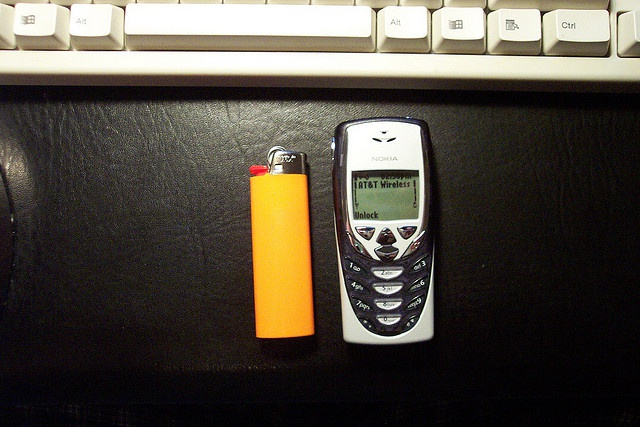Describe the objects in this image and their specific colors. I can see keyboard in black, ivory, tan, and beige tones and cell phone in tan, black, ivory, gray, and darkgray tones in this image. 